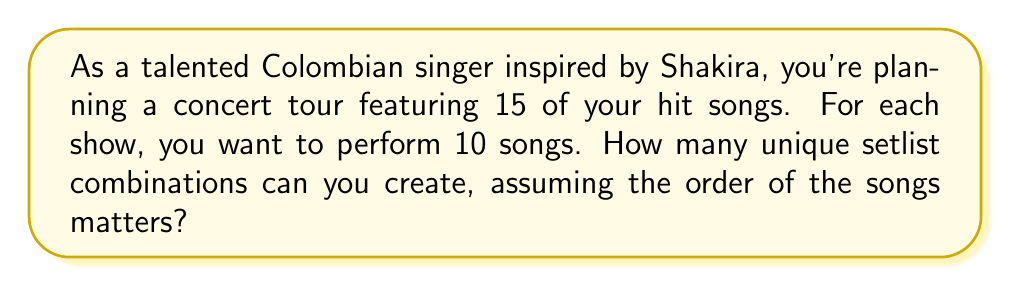Solve this math problem. Let's approach this step-by-step:

1) This is a permutation problem. We are selecting 10 songs out of 15, and the order matters.

2) The formula for permutations is:

   $$P(n,r) = \frac{n!}{(n-r)!}$$

   Where $n$ is the total number of items to choose from, and $r$ is the number of items being chosen.

3) In this case, $n = 15$ (total songs) and $r = 10$ (songs in each setlist).

4) Plugging these values into our formula:

   $$P(15,10) = \frac{15!}{(15-10)!} = \frac{15!}{5!}$$

5) Let's calculate this:
   
   $$\frac{15!}{5!} = \frac{15 \times 14 \times 13 \times 12 \times 11 \times 10!}{5!}$$

6) The 10! cancels out in the numerator and denominator:

   $$15 \times 14 \times 13 \times 12 \times 11 = 360,360$$

Therefore, you can create 360,360 unique setlist combinations for your concert tour.
Answer: 360,360 